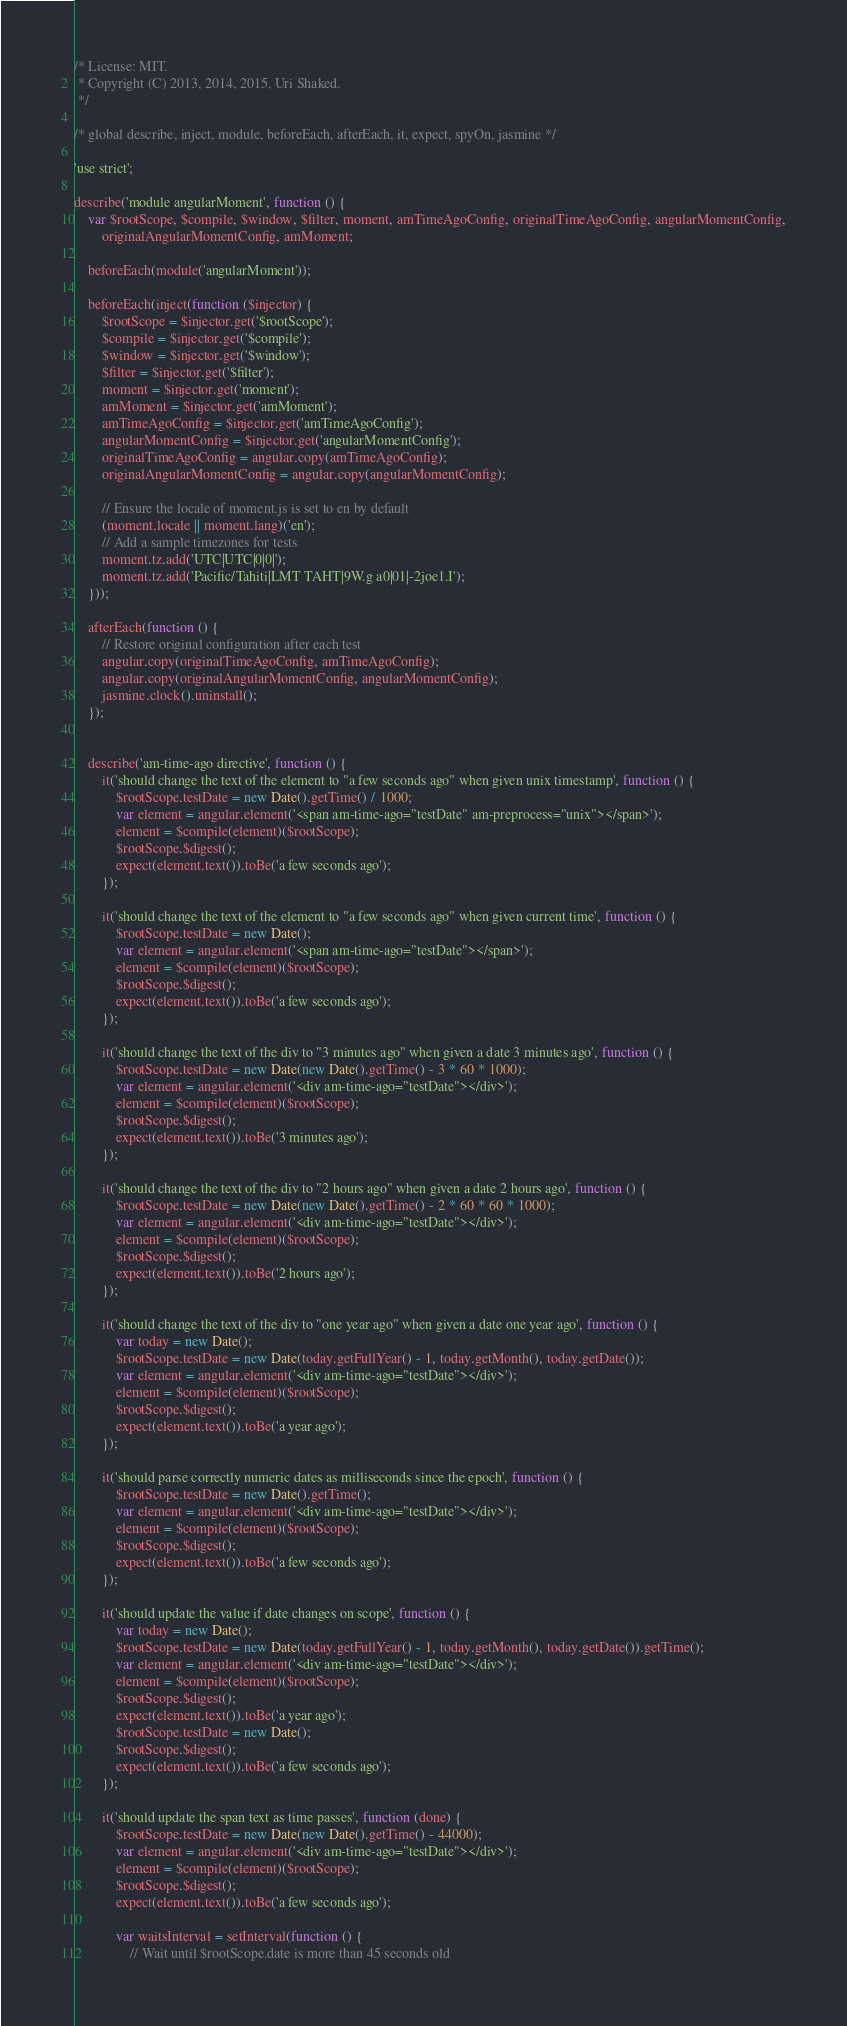Convert code to text. <code><loc_0><loc_0><loc_500><loc_500><_JavaScript_>/* License: MIT.
 * Copyright (C) 2013, 2014, 2015, Uri Shaked.
 */

/* global describe, inject, module, beforeEach, afterEach, it, expect, spyOn, jasmine */

'use strict';

describe('module angularMoment', function () {
	var $rootScope, $compile, $window, $filter, moment, amTimeAgoConfig, originalTimeAgoConfig, angularMomentConfig,
		originalAngularMomentConfig, amMoment;

	beforeEach(module('angularMoment'));

	beforeEach(inject(function ($injector) {
		$rootScope = $injector.get('$rootScope');
		$compile = $injector.get('$compile');
		$window = $injector.get('$window');
		$filter = $injector.get('$filter');
		moment = $injector.get('moment');
		amMoment = $injector.get('amMoment');
		amTimeAgoConfig = $injector.get('amTimeAgoConfig');
		angularMomentConfig = $injector.get('angularMomentConfig');
		originalTimeAgoConfig = angular.copy(amTimeAgoConfig);
		originalAngularMomentConfig = angular.copy(angularMomentConfig);

		// Ensure the locale of moment.js is set to en by default
		(moment.locale || moment.lang)('en');
		// Add a sample timezones for tests
		moment.tz.add('UTC|UTC|0|0|');
		moment.tz.add('Pacific/Tahiti|LMT TAHT|9W.g a0|01|-2joe1.I');
	}));

	afterEach(function () {
		// Restore original configuration after each test
		angular.copy(originalTimeAgoConfig, amTimeAgoConfig);
		angular.copy(originalAngularMomentConfig, angularMomentConfig);
		jasmine.clock().uninstall();
	});


	describe('am-time-ago directive', function () {
		it('should change the text of the element to "a few seconds ago" when given unix timestamp', function () {
			$rootScope.testDate = new Date().getTime() / 1000;
			var element = angular.element('<span am-time-ago="testDate" am-preprocess="unix"></span>');
			element = $compile(element)($rootScope);
			$rootScope.$digest();
			expect(element.text()).toBe('a few seconds ago');
		});

		it('should change the text of the element to "a few seconds ago" when given current time', function () {
			$rootScope.testDate = new Date();
			var element = angular.element('<span am-time-ago="testDate"></span>');
			element = $compile(element)($rootScope);
			$rootScope.$digest();
			expect(element.text()).toBe('a few seconds ago');
		});

		it('should change the text of the div to "3 minutes ago" when given a date 3 minutes ago', function () {
			$rootScope.testDate = new Date(new Date().getTime() - 3 * 60 * 1000);
			var element = angular.element('<div am-time-ago="testDate"></div>');
			element = $compile(element)($rootScope);
			$rootScope.$digest();
			expect(element.text()).toBe('3 minutes ago');
		});

		it('should change the text of the div to "2 hours ago" when given a date 2 hours ago', function () {
			$rootScope.testDate = new Date(new Date().getTime() - 2 * 60 * 60 * 1000);
			var element = angular.element('<div am-time-ago="testDate"></div>');
			element = $compile(element)($rootScope);
			$rootScope.$digest();
			expect(element.text()).toBe('2 hours ago');
		});

		it('should change the text of the div to "one year ago" when given a date one year ago', function () {
			var today = new Date();
			$rootScope.testDate = new Date(today.getFullYear() - 1, today.getMonth(), today.getDate());
			var element = angular.element('<div am-time-ago="testDate"></div>');
			element = $compile(element)($rootScope);
			$rootScope.$digest();
			expect(element.text()).toBe('a year ago');
		});

		it('should parse correctly numeric dates as milliseconds since the epoch', function () {
			$rootScope.testDate = new Date().getTime();
			var element = angular.element('<div am-time-ago="testDate"></div>');
			element = $compile(element)($rootScope);
			$rootScope.$digest();
			expect(element.text()).toBe('a few seconds ago');
		});

		it('should update the value if date changes on scope', function () {
			var today = new Date();
			$rootScope.testDate = new Date(today.getFullYear() - 1, today.getMonth(), today.getDate()).getTime();
			var element = angular.element('<div am-time-ago="testDate"></div>');
			element = $compile(element)($rootScope);
			$rootScope.$digest();
			expect(element.text()).toBe('a year ago');
			$rootScope.testDate = new Date();
			$rootScope.$digest();
			expect(element.text()).toBe('a few seconds ago');
		});

		it('should update the span text as time passes', function (done) {
			$rootScope.testDate = new Date(new Date().getTime() - 44000);
			var element = angular.element('<div am-time-ago="testDate"></div>');
			element = $compile(element)($rootScope);
			$rootScope.$digest();
			expect(element.text()).toBe('a few seconds ago');

			var waitsInterval = setInterval(function () {
				// Wait until $rootScope.date is more than 45 seconds old</code> 